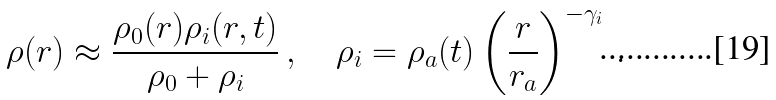<formula> <loc_0><loc_0><loc_500><loc_500>\rho ( r ) \approx \frac { \rho _ { 0 } ( r ) \rho _ { i } ( r , t ) } { \rho _ { 0 } + \rho _ { i } } \, , \quad \rho _ { i } = \rho _ { a } ( t ) \left ( \frac { r } { r _ { a } } \right ) ^ { - \gamma _ { i } } \, .</formula> 